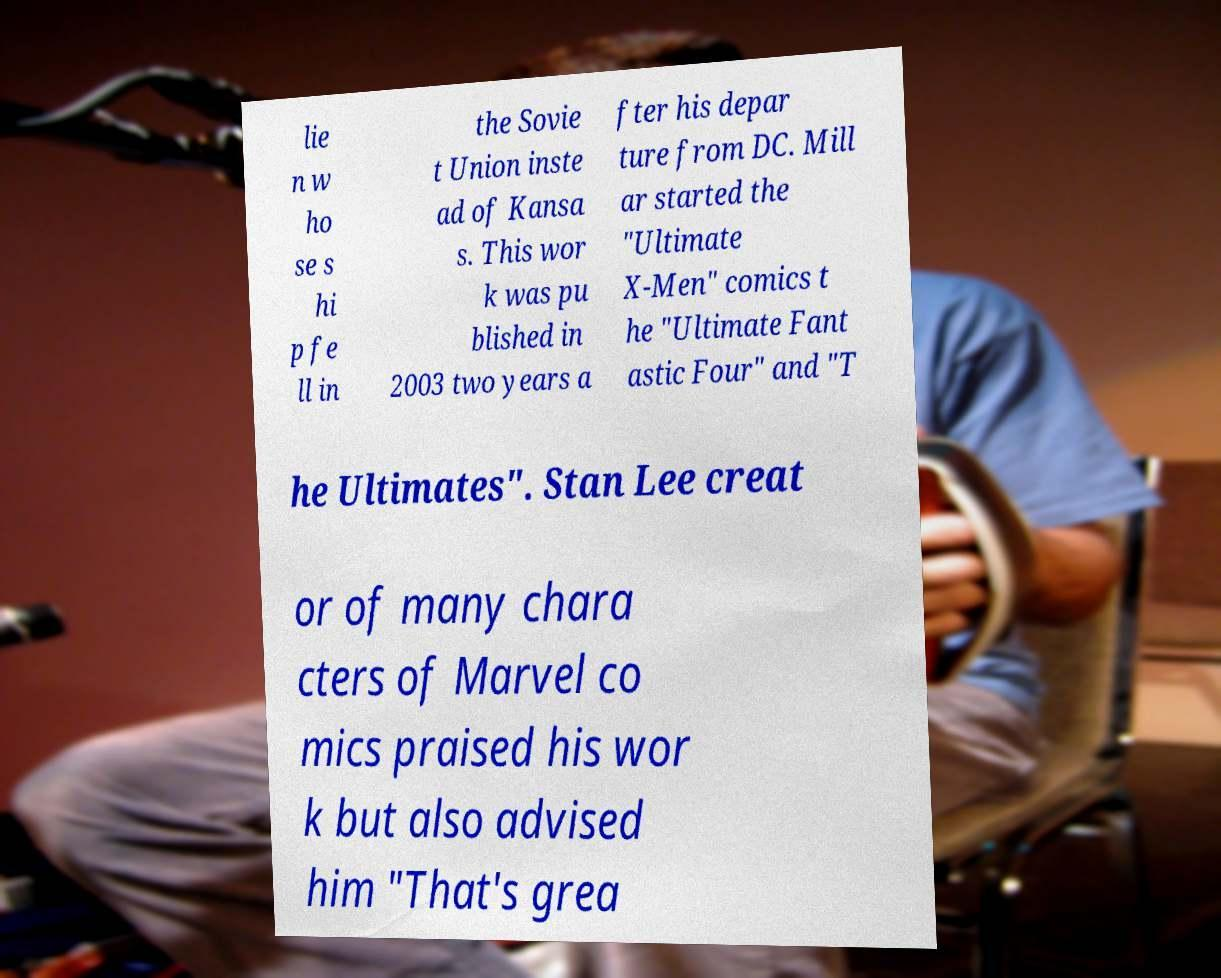What messages or text are displayed in this image? I need them in a readable, typed format. lie n w ho se s hi p fe ll in the Sovie t Union inste ad of Kansa s. This wor k was pu blished in 2003 two years a fter his depar ture from DC. Mill ar started the "Ultimate X-Men" comics t he "Ultimate Fant astic Four" and "T he Ultimates". Stan Lee creat or of many chara cters of Marvel co mics praised his wor k but also advised him "That's grea 